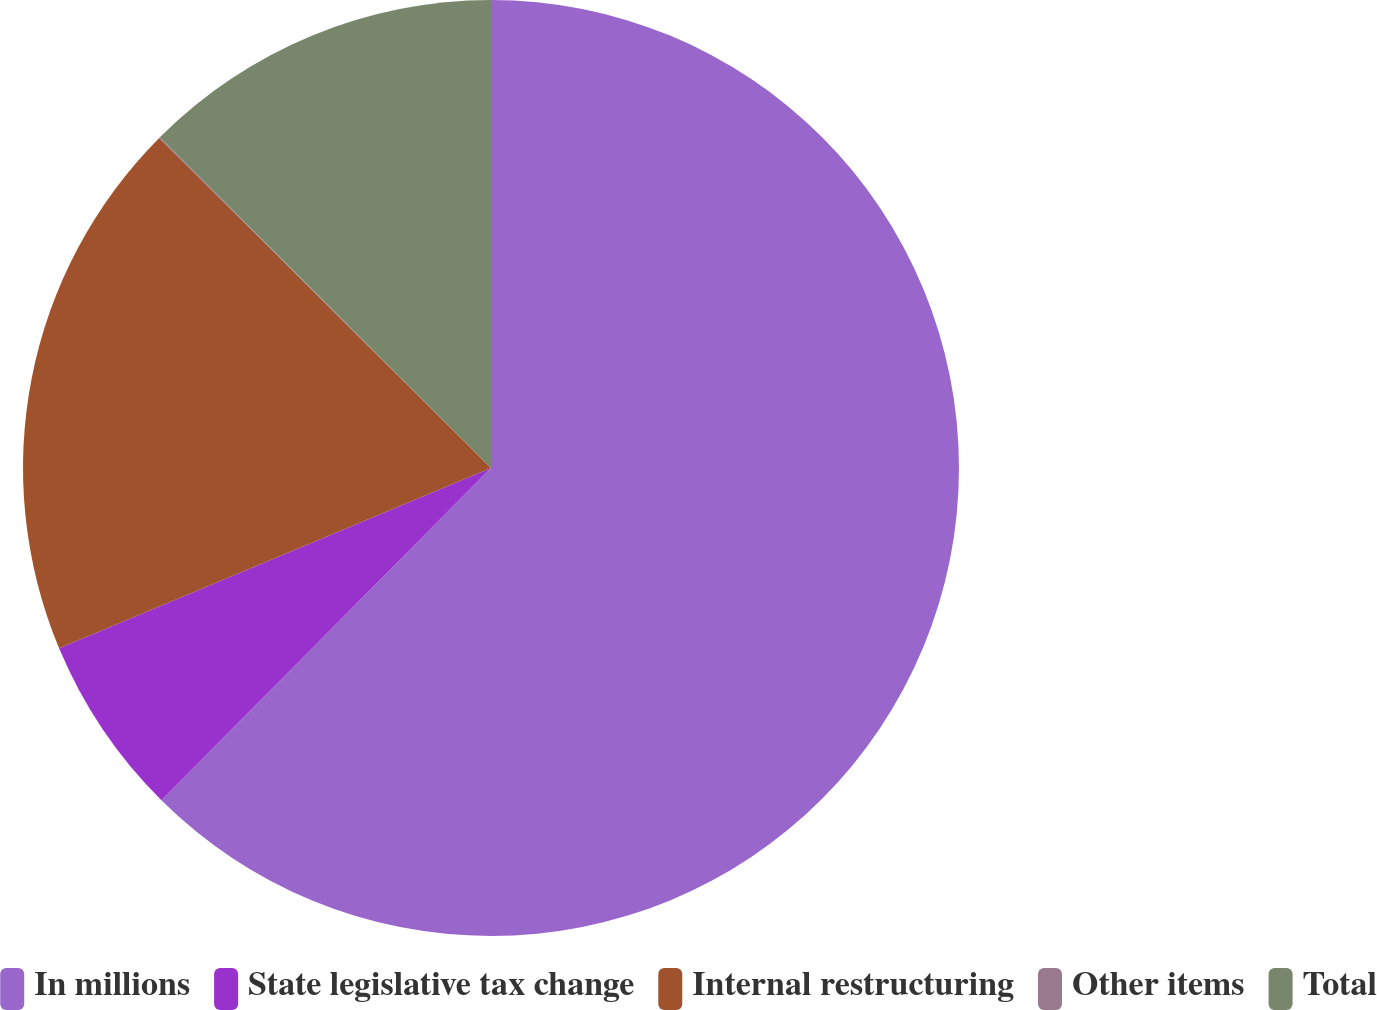Convert chart to OTSL. <chart><loc_0><loc_0><loc_500><loc_500><pie_chart><fcel>In millions<fcel>State legislative tax change<fcel>Internal restructuring<fcel>Other items<fcel>Total<nl><fcel>62.43%<fcel>6.27%<fcel>18.75%<fcel>0.03%<fcel>12.51%<nl></chart> 